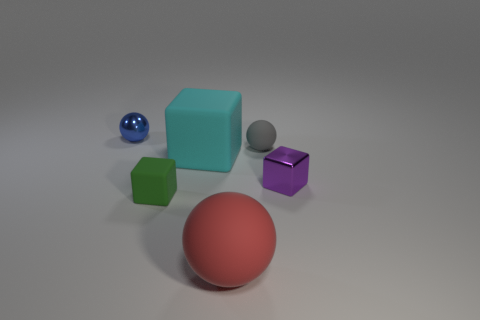What material do the objects in the image seem to be made of? The objects in the image appear to be rendered with materials that mimic glass, plastic, and metal. For example, the small blue sphere has a reflective surface that suggests it is made of a glass-like material, while the turquoise and green cubes have a matte finish akin to plastic, and the small cube to the right of the green one exhibits a metallic sheen. 